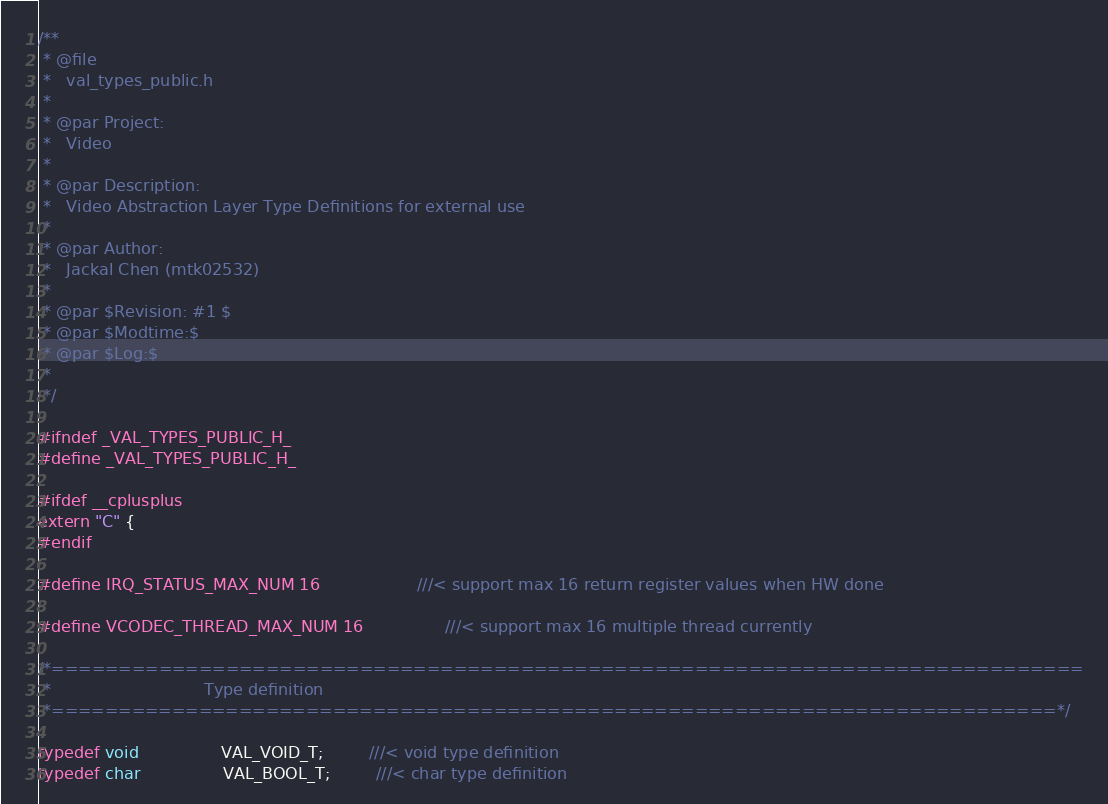Convert code to text. <code><loc_0><loc_0><loc_500><loc_500><_C_>/**
 * @file
 *   val_types_public.h
 *
 * @par Project:
 *   Video
 *
 * @par Description:
 *   Video Abstraction Layer Type Definitions for external use
 *
 * @par Author:
 *   Jackal Chen (mtk02532)
 *
 * @par $Revision: #1 $
 * @par $Modtime:$
 * @par $Log:$
 *
 */

#ifndef _VAL_TYPES_PUBLIC_H_
#define _VAL_TYPES_PUBLIC_H_

#ifdef __cplusplus
extern "C" {
#endif

#define IRQ_STATUS_MAX_NUM 16                   ///< support max 16 return register values when HW done

#define VCODEC_THREAD_MAX_NUM 16                ///< support max 16 multiple thread currently

/*=============================================================================
 *                              Type definition
 *===========================================================================*/

typedef void                VAL_VOID_T;         ///< void type definition
typedef char                VAL_BOOL_T;         ///< char type definition</code> 